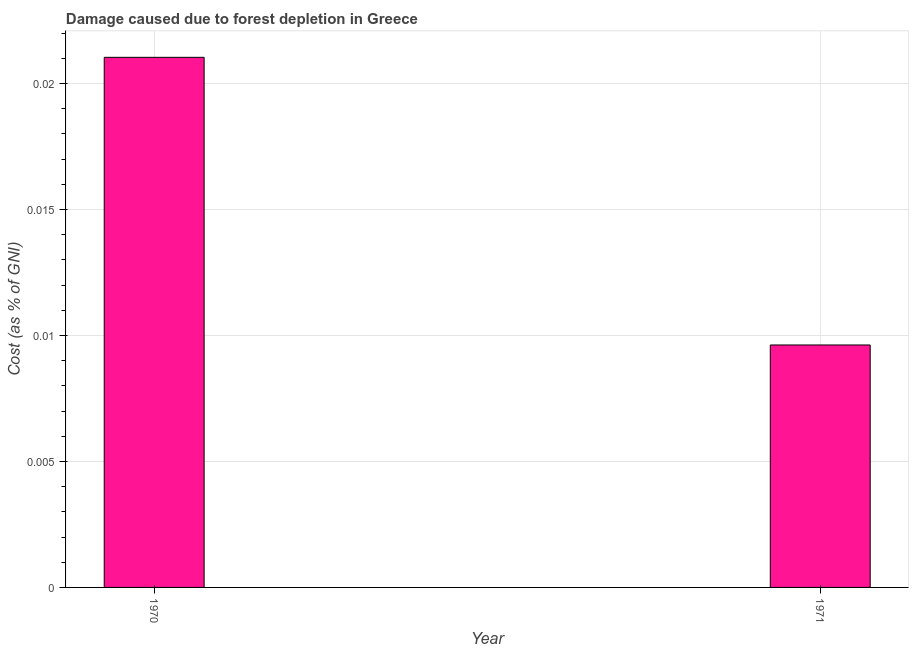Does the graph contain any zero values?
Keep it short and to the point. No. Does the graph contain grids?
Provide a succinct answer. Yes. What is the title of the graph?
Keep it short and to the point. Damage caused due to forest depletion in Greece. What is the label or title of the X-axis?
Ensure brevity in your answer.  Year. What is the label or title of the Y-axis?
Give a very brief answer. Cost (as % of GNI). What is the damage caused due to forest depletion in 1970?
Ensure brevity in your answer.  0.02. Across all years, what is the maximum damage caused due to forest depletion?
Your response must be concise. 0.02. Across all years, what is the minimum damage caused due to forest depletion?
Your response must be concise. 0.01. In which year was the damage caused due to forest depletion maximum?
Keep it short and to the point. 1970. In which year was the damage caused due to forest depletion minimum?
Offer a terse response. 1971. What is the sum of the damage caused due to forest depletion?
Offer a terse response. 0.03. What is the difference between the damage caused due to forest depletion in 1970 and 1971?
Keep it short and to the point. 0.01. What is the average damage caused due to forest depletion per year?
Offer a terse response. 0.01. What is the median damage caused due to forest depletion?
Offer a terse response. 0.02. In how many years, is the damage caused due to forest depletion greater than 0.003 %?
Your response must be concise. 2. What is the ratio of the damage caused due to forest depletion in 1970 to that in 1971?
Ensure brevity in your answer.  2.19. Are all the bars in the graph horizontal?
Provide a short and direct response. No. How many years are there in the graph?
Keep it short and to the point. 2. What is the difference between two consecutive major ticks on the Y-axis?
Make the answer very short. 0.01. What is the Cost (as % of GNI) of 1970?
Keep it short and to the point. 0.02. What is the Cost (as % of GNI) in 1971?
Your answer should be very brief. 0.01. What is the difference between the Cost (as % of GNI) in 1970 and 1971?
Your response must be concise. 0.01. What is the ratio of the Cost (as % of GNI) in 1970 to that in 1971?
Ensure brevity in your answer.  2.19. 